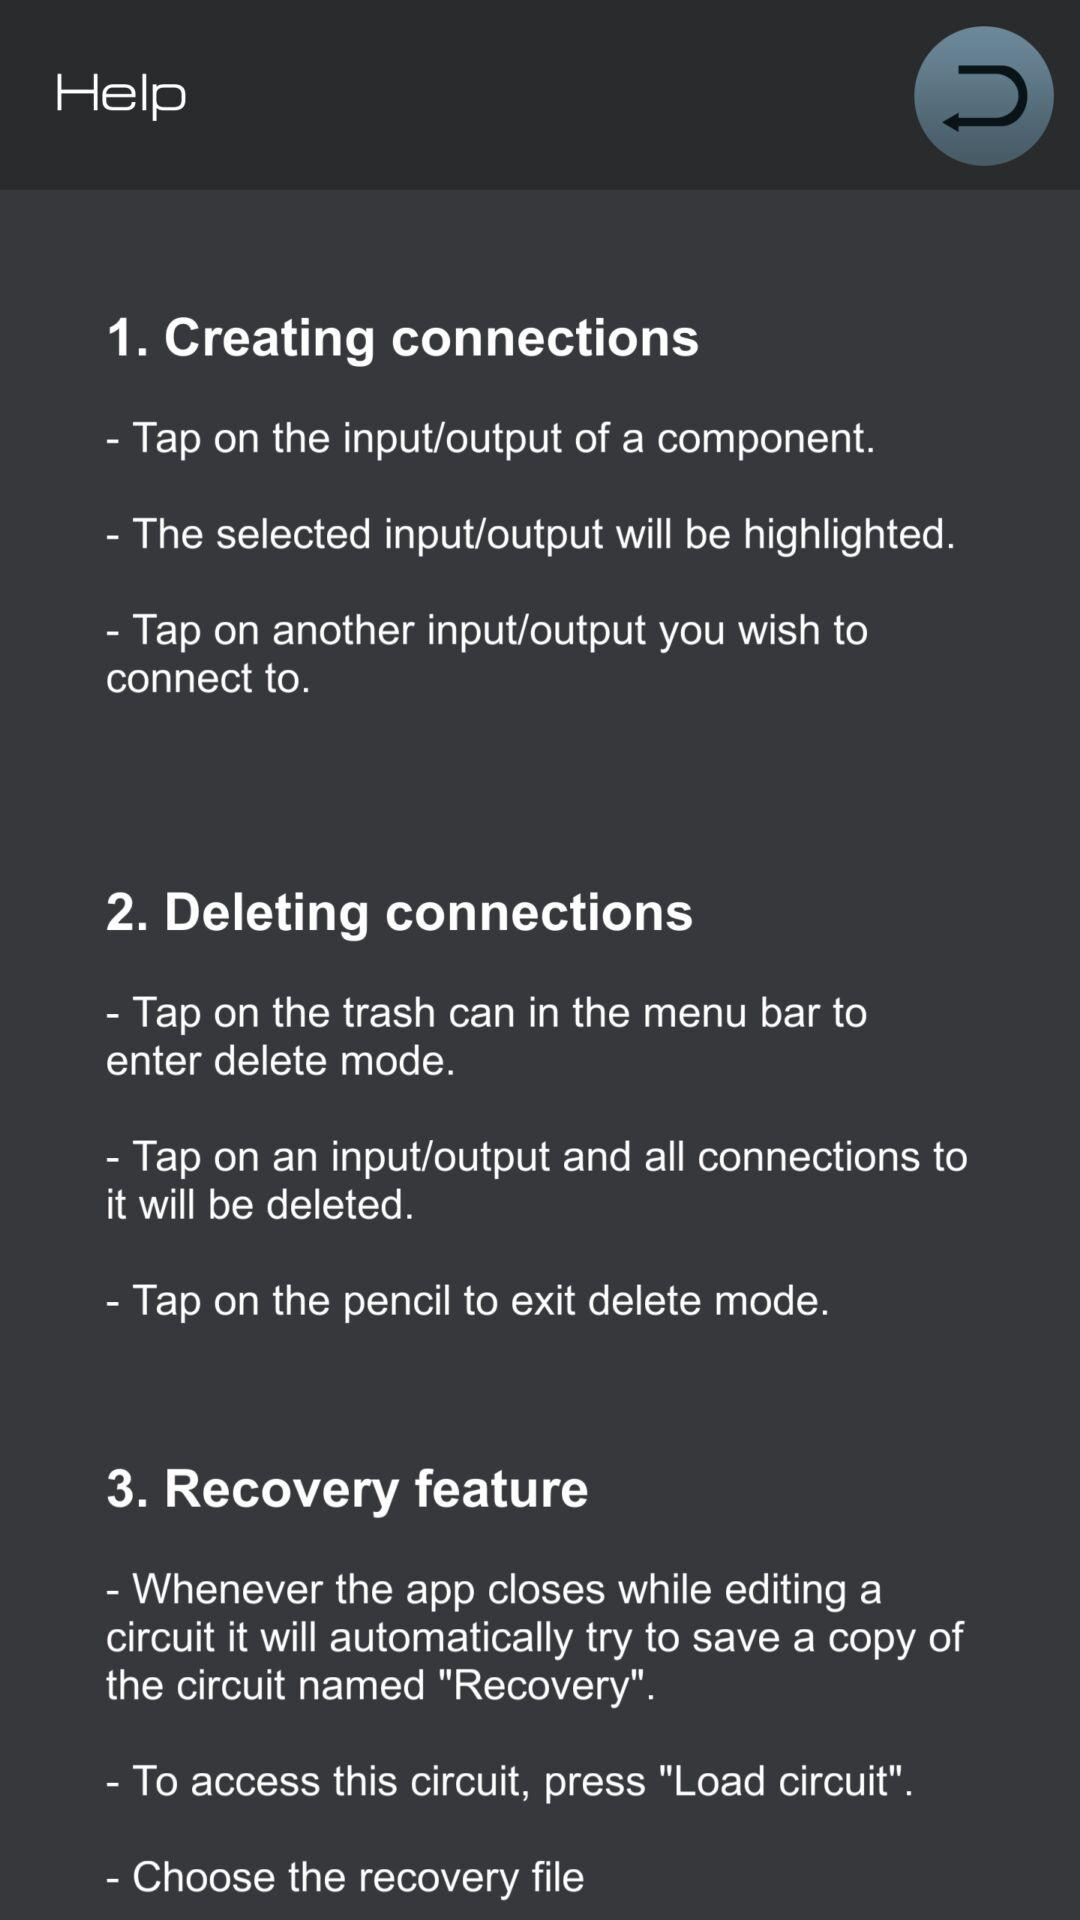How many steps are there in creating a connection?
Answer the question using a single word or phrase. 3 